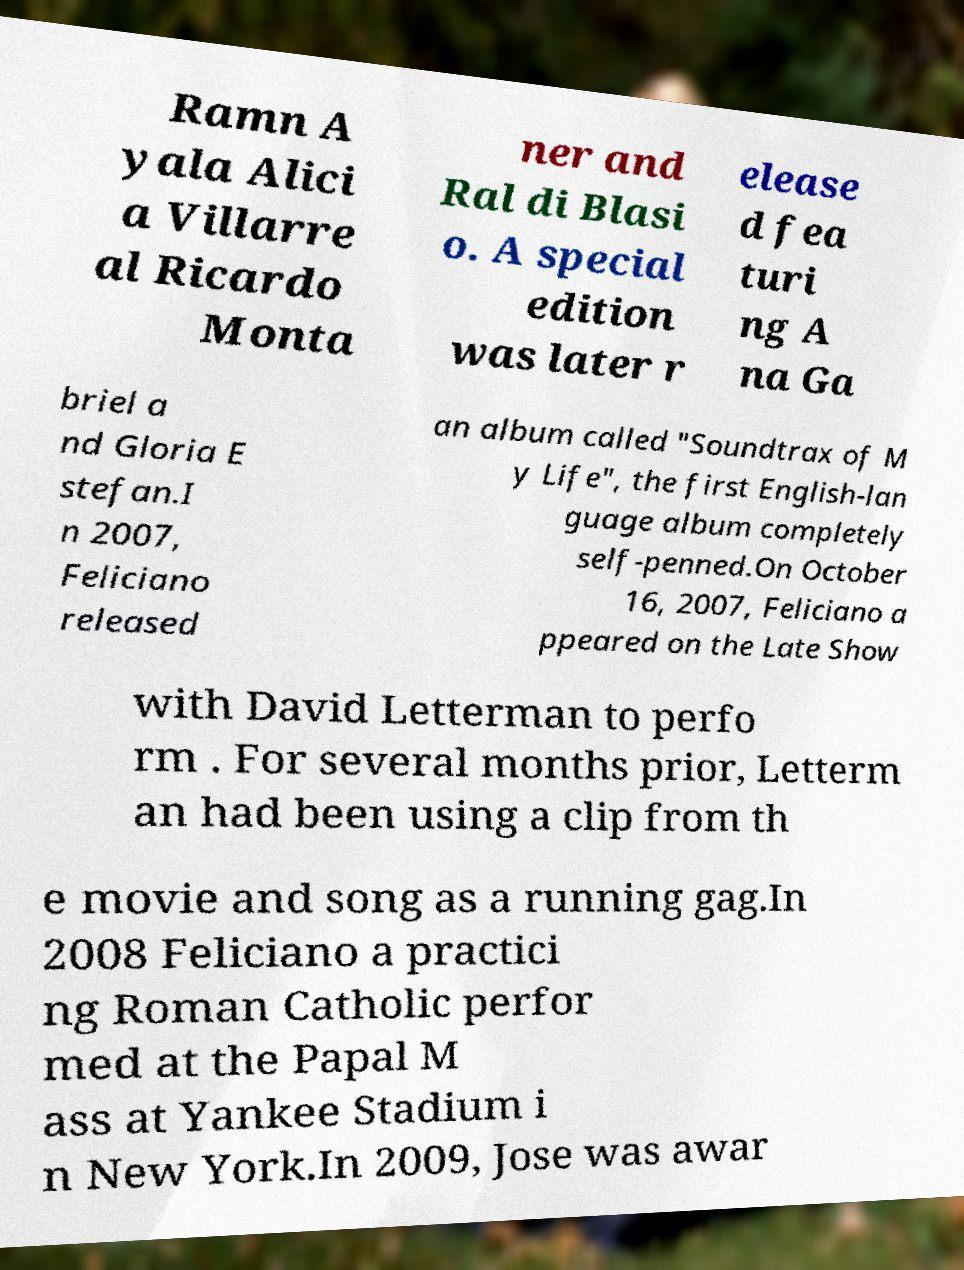Can you accurately transcribe the text from the provided image for me? Ramn A yala Alici a Villarre al Ricardo Monta ner and Ral di Blasi o. A special edition was later r elease d fea turi ng A na Ga briel a nd Gloria E stefan.I n 2007, Feliciano released an album called "Soundtrax of M y Life", the first English-lan guage album completely self-penned.On October 16, 2007, Feliciano a ppeared on the Late Show with David Letterman to perfo rm . For several months prior, Letterm an had been using a clip from th e movie and song as a running gag.In 2008 Feliciano a practici ng Roman Catholic perfor med at the Papal M ass at Yankee Stadium i n New York.In 2009, Jose was awar 